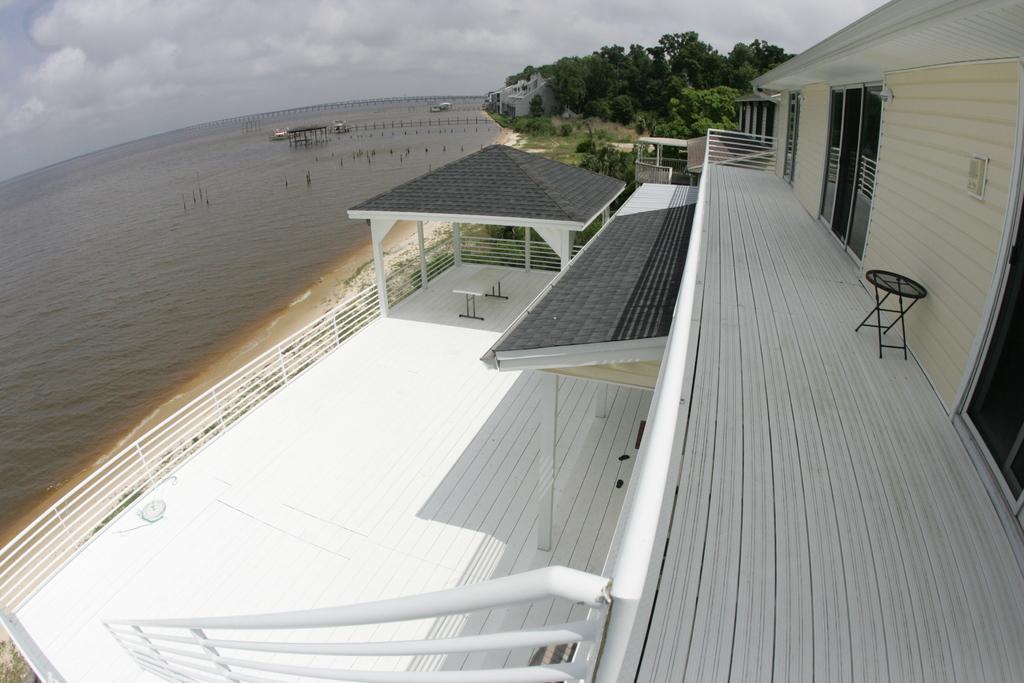Could you give a brief overview of what you see in this image? In the picture I can see the water, a house, roof, a table, fence, balcony, trees, glass doors and some other objects. In the background I can see boats on the water, the sky and some other objects. 